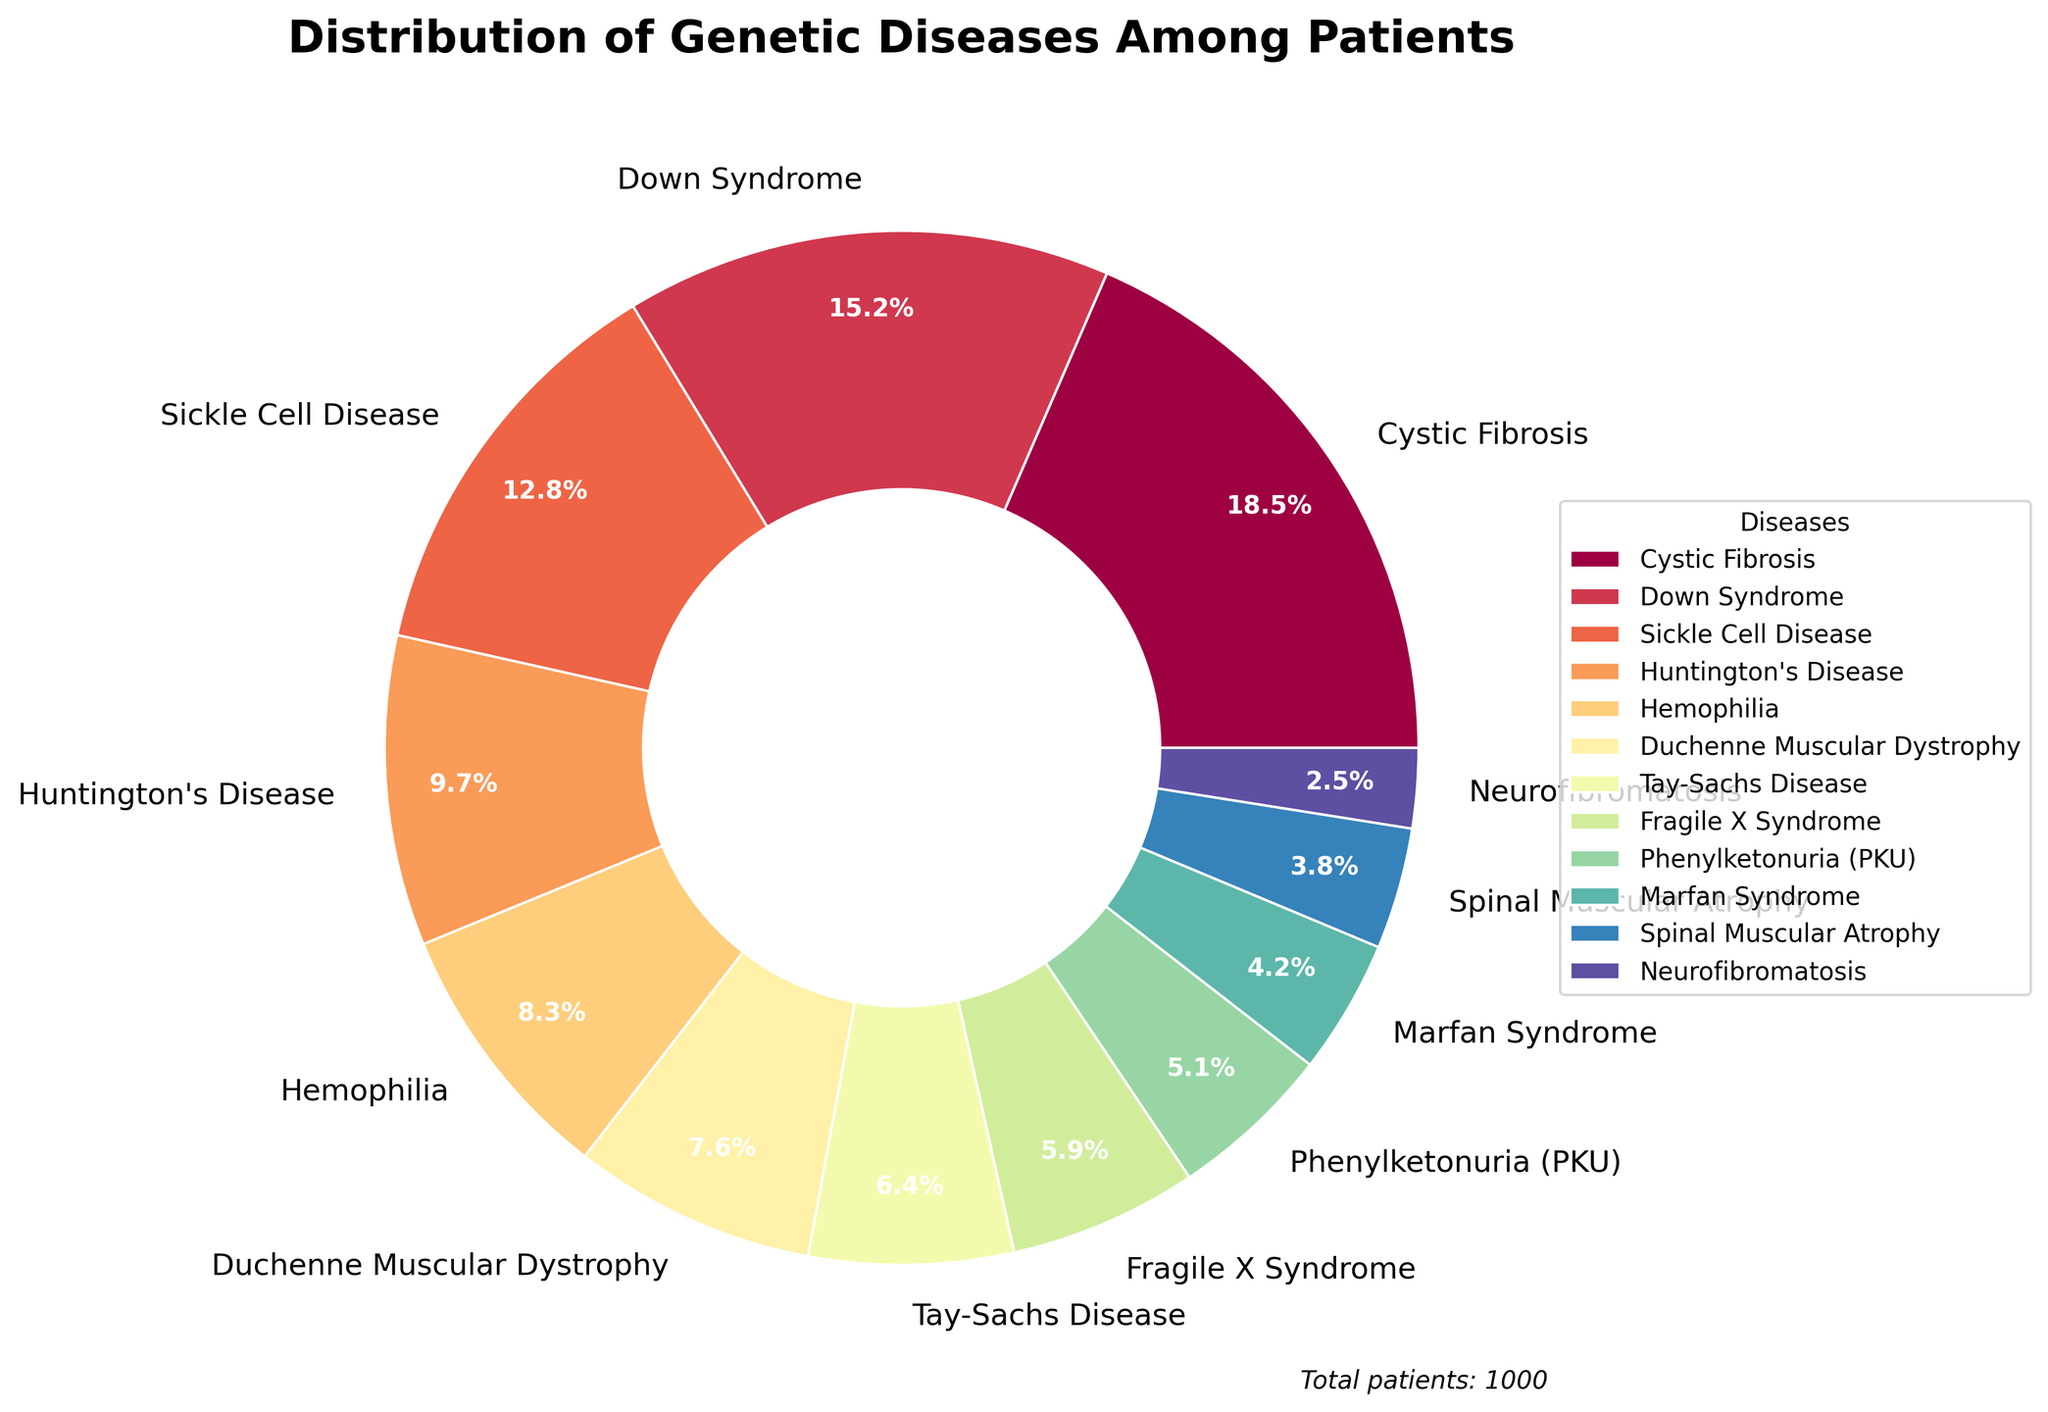What percentage of patients have either Down Syndrome or Sickle Cell Disease? Add the percentages of Down Syndrome (15.2) and Sickle Cell Disease (12.8). 15.2 + 12.8 = 28.0
Answer: 28.0 Which genetic disease has the highest percentage of patients? Referring to the pie chart, the segment with the highest percentage is Cystic Fibrosis at 18.5%.
Answer: Cystic Fibrosis Which genetic disease is represented by a blue sector in the pie chart? Identify the color used in the pie chart; for instance, if the blue sector corresponds to Phenylketonuria (PKU) percentage of 5.1%, it would be the answer.
Answer: Phenylketonuria (PKU) How much more common is Huntington's Disease compared to Spinal Muscular Atrophy? Subtract the percentage of Spinal Muscular Atrophy (3.8) from Huntington's Disease (9.7). 9.7 - 3.8 = 5.9
Answer: 5.9 If 1000 patients were observed, how many of them were diagnosed with Hemophilia? Multiply the percentage of Hemophilia (8.3) by 1000. 0.083 * 1000 = 83
Answer: 83 What is the combined percentage of Duchenne Muscular Dystrophy, Tay-Sachs Disease, and Marfan Syndrome? Add the percentages of Duchenne Muscular Dystrophy (7.6), Tay-Sachs Disease (6.4), and Marfan Syndrome (4.2). 7.6 + 6.4 + 4.2 = 18.2
Answer: 18.2 Which is less common, Neurofibromatosis or Fragile X Syndrome, and by how much? Neurofibromatosis has a percentage of 2.5, and Fragile X Syndrome has 5.9. Subtract Neurofibromatosis from Fragile X Syndrome. 5.9 - 2.5 = 3.4
Answer: Neurofibromatosis by 3.4 What is the difference in percentage between Cystic Fibrosis and Hemophilia? Subtract the percentage of Hemophilia (8.3) from Cystic Fibrosis (18.5). 18.5 - 8.3 = 10.2
Answer: 10.2 Which diseases have a combined percentage close to or greater than 20%? From the chart, Down Syndrome (15.2) and Sickle Cell Disease (12.8) add to 28, which is greater than 20.
Answer: Down Syndrome and Sickle Cell Disease What is the median percentage value of the genetic diseases listed? List the percentages in ascending order, find the middle value of the sorted list: [2.5, 3.8, 4.2, 5.1, 5.9, 6.4, 7.6, 8.3, 9.7, 12.8, 15.2, 18.5]; the middle values are 6.4 and 7.6. Average them (6.4 + 7.6) / 2 = 7.0
Answer: 7.0 